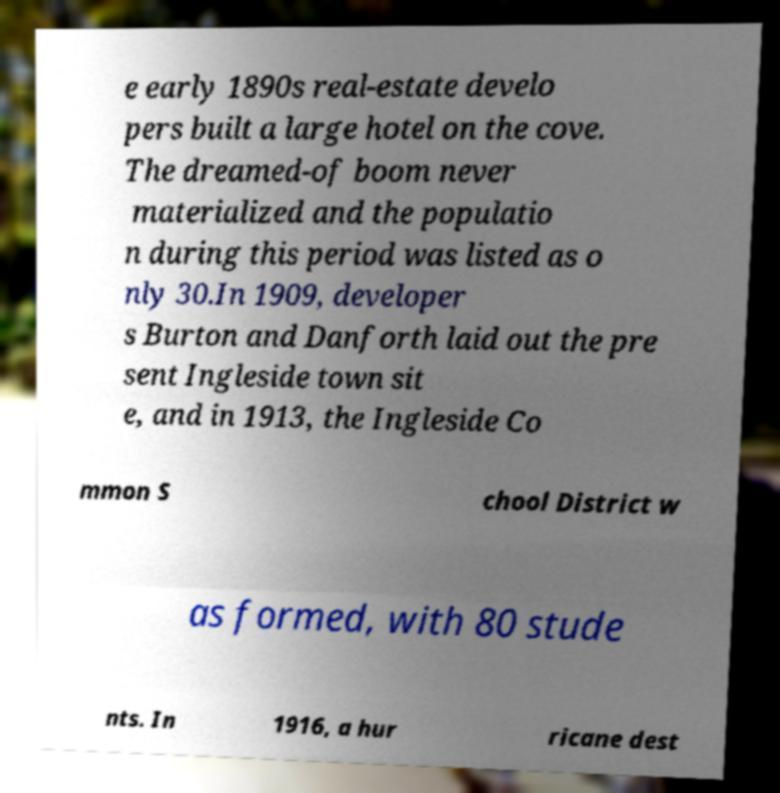I need the written content from this picture converted into text. Can you do that? e early 1890s real-estate develo pers built a large hotel on the cove. The dreamed-of boom never materialized and the populatio n during this period was listed as o nly 30.In 1909, developer s Burton and Danforth laid out the pre sent Ingleside town sit e, and in 1913, the Ingleside Co mmon S chool District w as formed, with 80 stude nts. In 1916, a hur ricane dest 